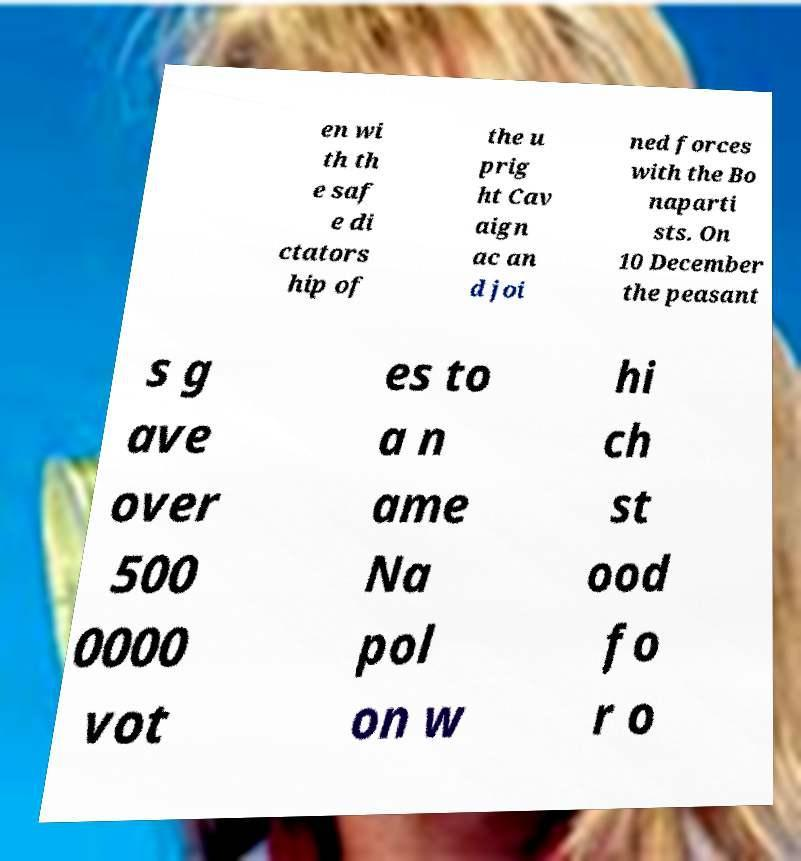Can you accurately transcribe the text from the provided image for me? en wi th th e saf e di ctators hip of the u prig ht Cav aign ac an d joi ned forces with the Bo naparti sts. On 10 December the peasant s g ave over 500 0000 vot es to a n ame Na pol on w hi ch st ood fo r o 